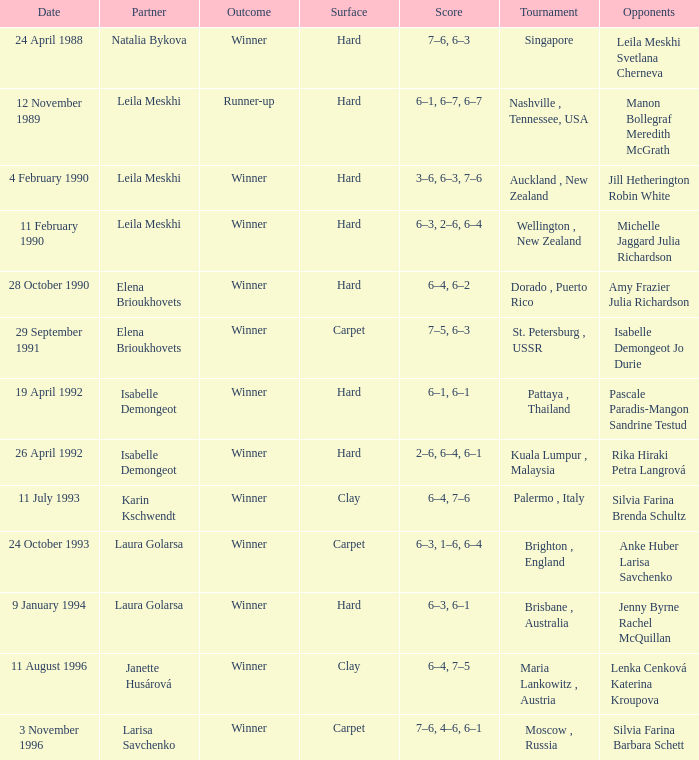Who was the Partner in a game with the Score of 6–4, 6–2 on a hard surface? Elena Brioukhovets. 